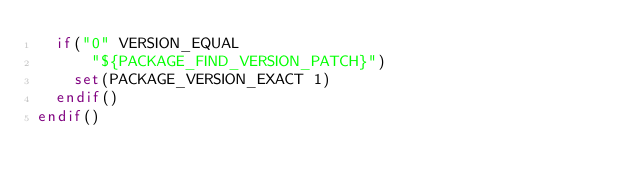<code> <loc_0><loc_0><loc_500><loc_500><_CMake_>  if("0" VERSION_EQUAL
      "${PACKAGE_FIND_VERSION_PATCH}")
    set(PACKAGE_VERSION_EXACT 1)
  endif()
endif()
</code> 